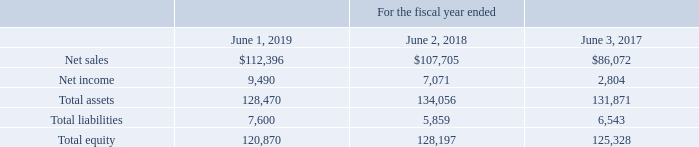3. Investment in Unconsolidated Entities
The Company has several investments in unconsolidated entities that are accounted for using the equity method of accounting. Red River Valley Egg Farm, LLC ("Red River") operates a cage-free shell egg production complex near Bogota, Texas. Specialty Eggs, LLC ("Specialty Eggs") owns the Egg-Land's Best franchise for most of Georgia and South Carolina, as well as a portion of western North Carolina and eastern Alabama. Southwest Specialty Eggs, LLC ("Southwest Specialty Eggs") owns the Egg-Land's Best franchise for Arizona, southern California and Clark County, Nevada (including Las Vegas). As of June 1, 2019, the Company owns 50% of each of Red River, Specialty Eggs, and Southwest Specialty Eggs. Equity method investments are included in “Investments in unconsolidated entities” in the accompanying Consolidated Balance Sheets and totaled $60.7 million and $64.2 million at June 1, 2019 and at June 2, 2018, respectively.
Equity in income of unconsolidated entities of $4.8 million, $3.5 million, and $1.4 million from these entities has been included in the Consolidated Statements of Operations for fiscal 2019, 2018, and 2017, respectively.
The condensed consolidated financial information for the Company's unconsolidated joint ventures was as follows (in thousands):
The Company is a member of Eggland’s Best, Inc. (“EB”), which is a cooperative. At June 1, 2019 and June 2, 2018, “Other long-term assets” as shown on the Company’s Consolidated Balance Sheet includes the cost of the Company’s investment in EB plus any qualified written allocations. The Company cannot exert significant influence over EB’s operating and financial activities; therefore, the Company accounts for this investment using the cost method. The carrying value of this investment at June 1, 2019 and June 2, 2018 was $2.6 million and $2.6 million, respectively.
What is the net sales in 2019?
Answer scale should be: thousand. 112,396. What is the increase in net sales from 2018 to 2019?
Answer scale should be: thousand. 112,396 - 107,705
Answer: 4691. What is the average total assets in 3 years?
Answer scale should be: thousand. (128,470 + 134,056 + 131,871) / 3
Answer: 131465.67. What is the Return on Assets in 2019?
Answer scale should be: percent. 9,490 / 128,470
Answer: 7.39. Which method is used by the company to account for investments? Investment using the cost method. What percentage each of Red River, Specialty Eggs, and Southwest Specialty Eggs is owned by the company? 50%. 